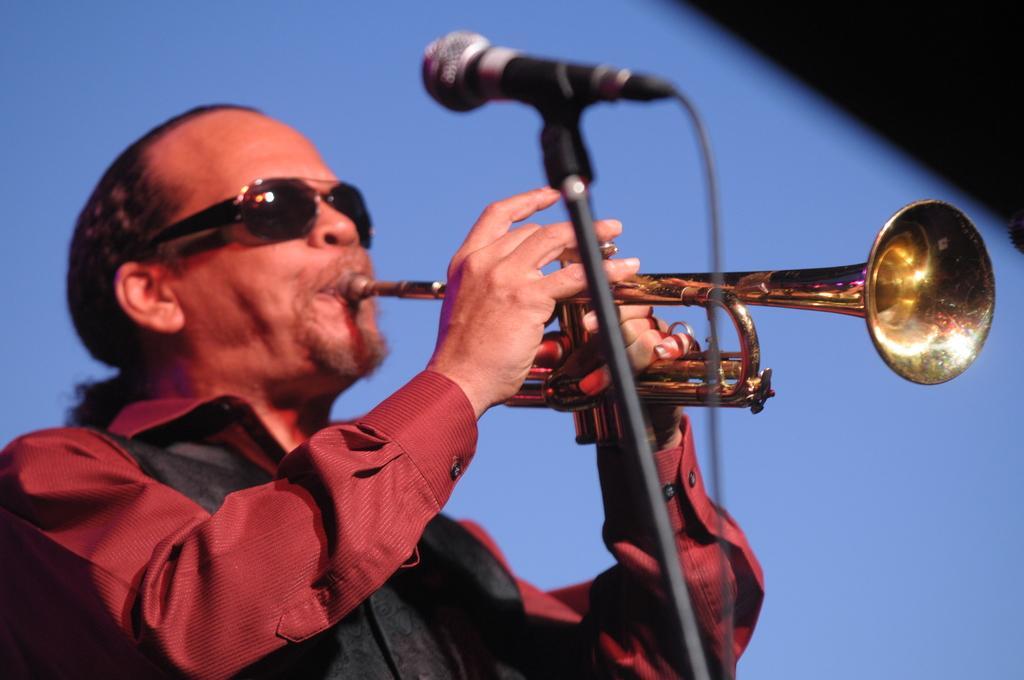How would you summarize this image in a sentence or two? In this picture there is a man wearing red color shirt with black sunglasses and playing the saxophone. In the front there is a black microphone stand. Behind there is a blue color background. 